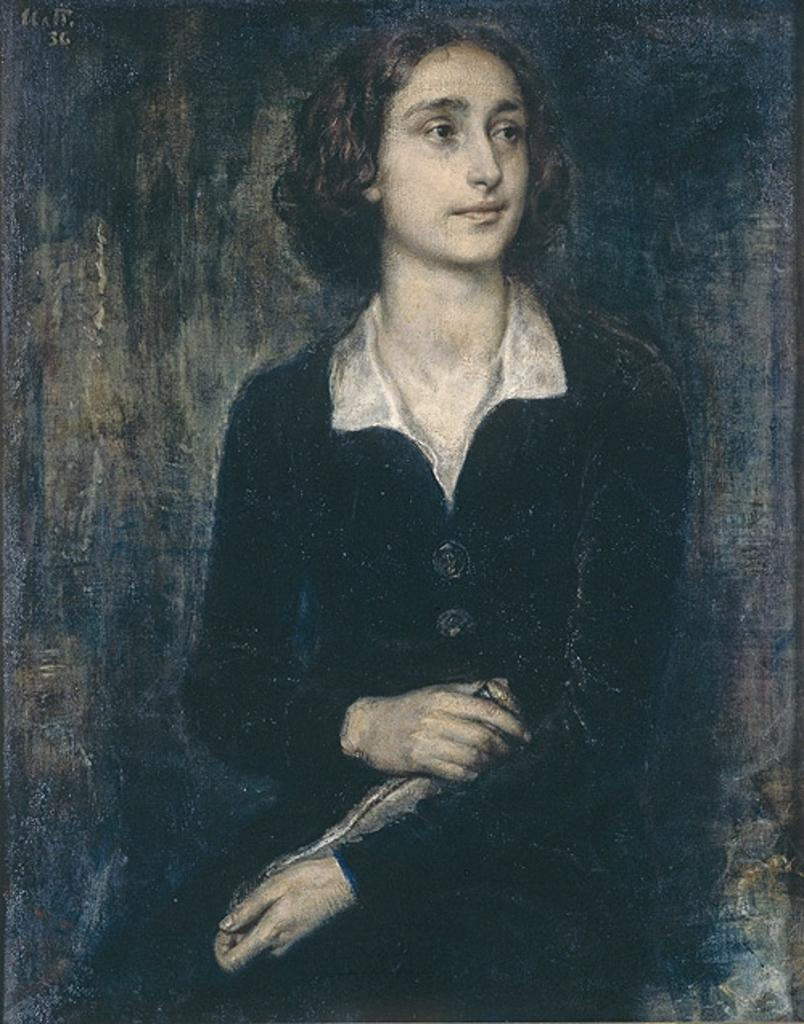What type of artwork is shown in the image? The image is a painting. Who or what is the main subject of the painting? The painting depicts a woman. What is the woman wearing in the painting? The woman is wearing a black dress. How would you describe the color scheme of the background in the painting? The background of the painting is in black and grey color. Can you see a snake slithering in the background of the painting? There is no snake present in the painting; the background is in black and grey color. 